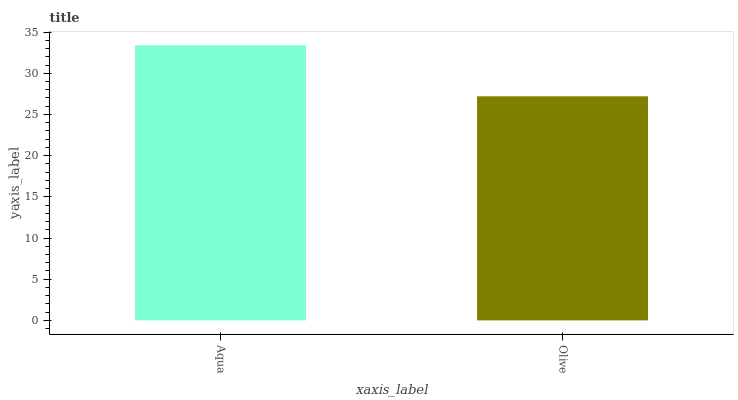Is Olive the maximum?
Answer yes or no. No. Is Aqua greater than Olive?
Answer yes or no. Yes. Is Olive less than Aqua?
Answer yes or no. Yes. Is Olive greater than Aqua?
Answer yes or no. No. Is Aqua less than Olive?
Answer yes or no. No. Is Aqua the high median?
Answer yes or no. Yes. Is Olive the low median?
Answer yes or no. Yes. Is Olive the high median?
Answer yes or no. No. Is Aqua the low median?
Answer yes or no. No. 